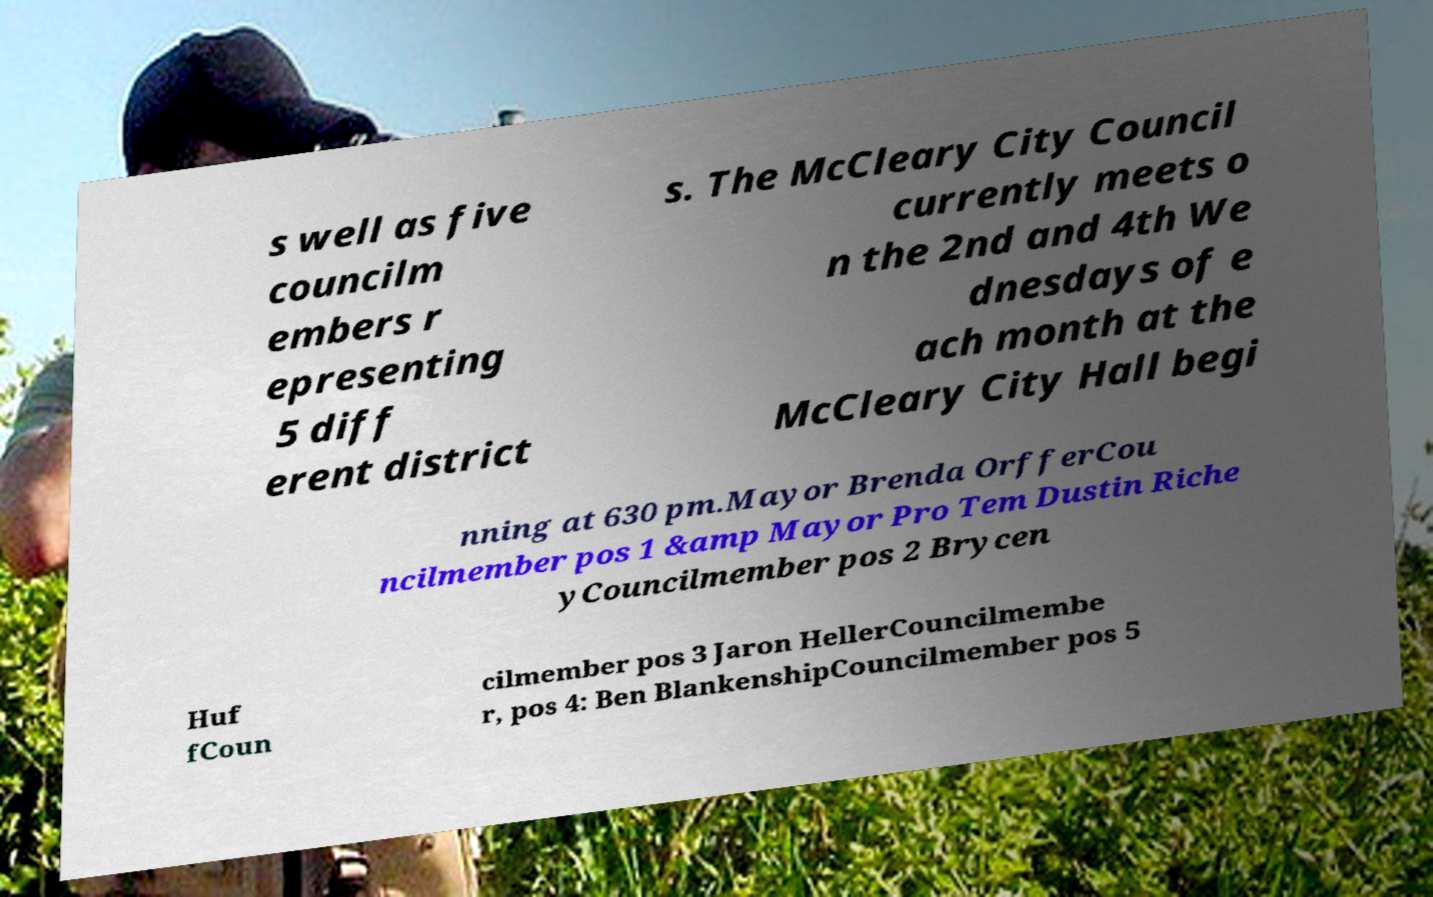Can you accurately transcribe the text from the provided image for me? s well as five councilm embers r epresenting 5 diff erent district s. The McCleary City Council currently meets o n the 2nd and 4th We dnesdays of e ach month at the McCleary City Hall begi nning at 630 pm.Mayor Brenda OrfferCou ncilmember pos 1 &amp Mayor Pro Tem Dustin Riche yCouncilmember pos 2 Brycen Huf fCoun cilmember pos 3 Jaron HellerCouncilmembe r, pos 4: Ben BlankenshipCouncilmember pos 5 